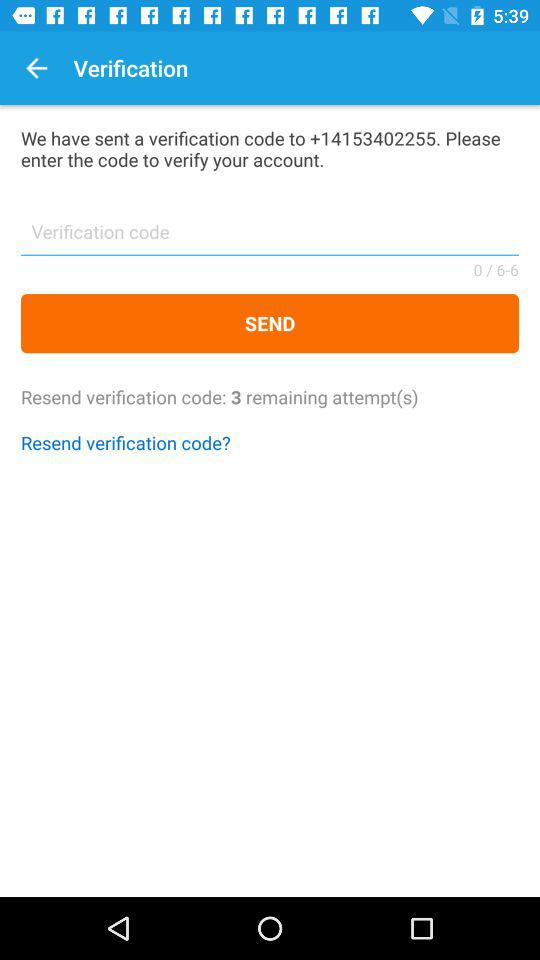How many attempts do I have left to resend the verification code?
Answer the question using a single word or phrase. 3 